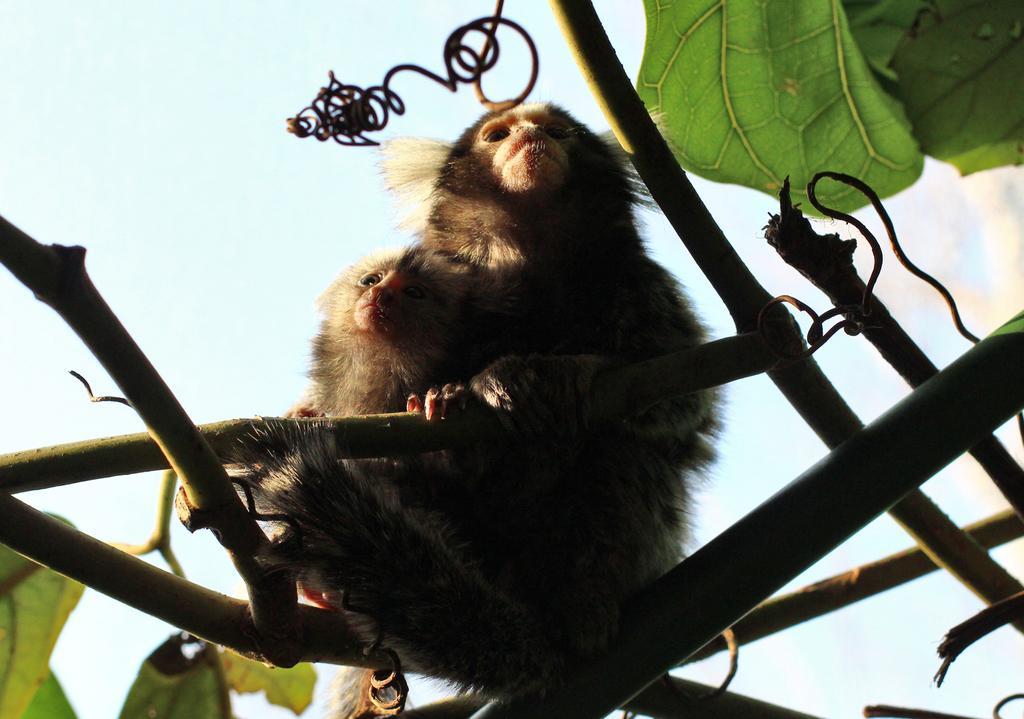Describe this image in one or two sentences. In this image we can see monkeys sitting on the branch of a tree. In the background we can see sky. 